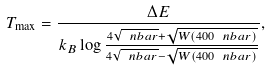<formula> <loc_0><loc_0><loc_500><loc_500>T _ { \max } = \frac { \Delta E } { k _ { B } \log \frac { 4 \sqrt { \ n b a r } + \sqrt { W ( 4 0 0 \ n b a r ) } } { 4 \sqrt { \ n b a r } - \sqrt { W ( 4 0 0 \ n b a r ) } } } ,</formula> 